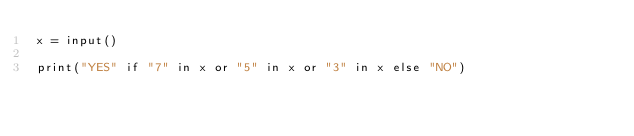Convert code to text. <code><loc_0><loc_0><loc_500><loc_500><_Python_>x = input()

print("YES" if "7" in x or "5" in x or "3" in x else "NO")</code> 